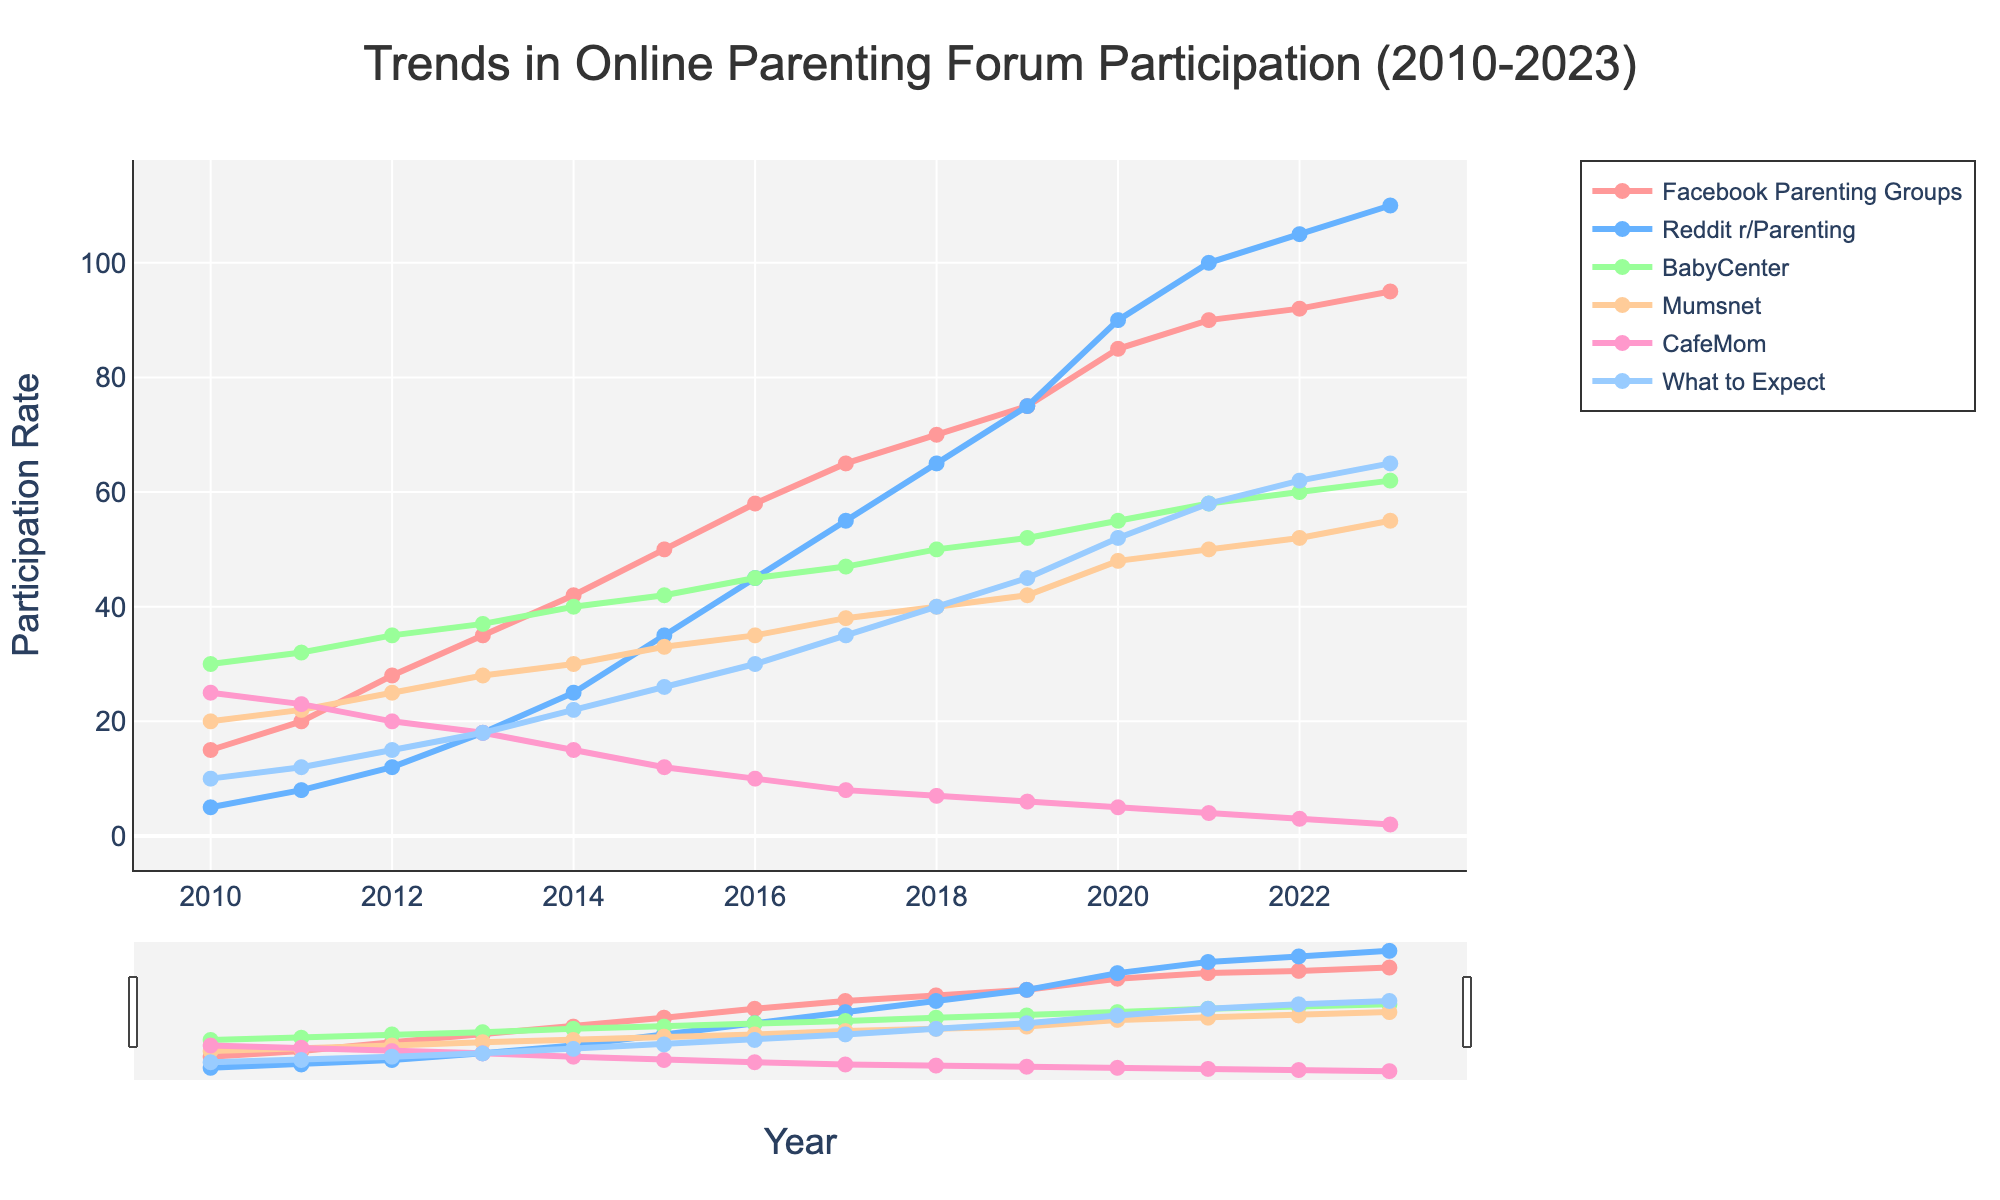What's the trend for Facebook Parenting Groups from 2010 to 2023? The line representing Facebook Parenting Groups shows a steady upward trend from 15 in 2010 to 95 in 2023.
Answer: Steadily upward Which platform had the highest participation rate in 2023? By looking at the endpoints of each line in 2023, Reddit r/Parenting has the highest participation rate at 110.
Answer: Reddit r/Parenting How does the participation rate of CafeMom change over the years? The line for CafeMom starts at 25 in 2010 and gradually declines to 2 by 2023.
Answer: Declining Between 2016 and 2018, which platform saw the greatest increase in participation rate? By comparing the slopes of the lines between 2016 and 2018, Reddit r/Parenting shows the greatest increase, from 45 to 65 (an increase of 20).
Answer: Reddit r/Parenting Which platform had the lowest participation rate in 2020? By comparing the points for 2020, CafeMom had the lowest rate at 5.
Answer: CafeMom What's the difference in participation rates between BabyCenter and What to Expect in 2023? In 2023, BabyCenter is at 62 and What to Expect is at 65. The difference is 65 - 62 = 3.
Answer: 3 Considering the entire period from 2010 to 2023, which platform shows the most stable trend in participation rates? By observing the slopes and curvature of the lines, BabyCenter has the most stable trend, with relatively small fluctuations compared to others.
Answer: BabyCenter How did participation in Mumsnet change between 2010 and 2020? The rate increased from 20 in 2010 to 48 in 2020.
Answer: Increased Which two platforms had the closest participation rates in 2015? In 2015, Mumsnet and What to Expect had participation rates of 33 and 26 respectively, which are closer compared to other pairs.
Answer: Mumsnet and What to Expect Comparing the beginning and the end of the period, which platform had the greatest absolute increase in participation rates? Facebook Parenting Groups increased from 15 in 2010 to 95 in 2023. The increase is 95 - 15 = 80, the greatest among all platforms.
Answer: Facebook Parenting Groups 